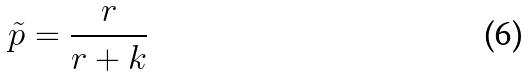Convert formula to latex. <formula><loc_0><loc_0><loc_500><loc_500>\tilde { p } = \frac { r } { r + k }</formula> 